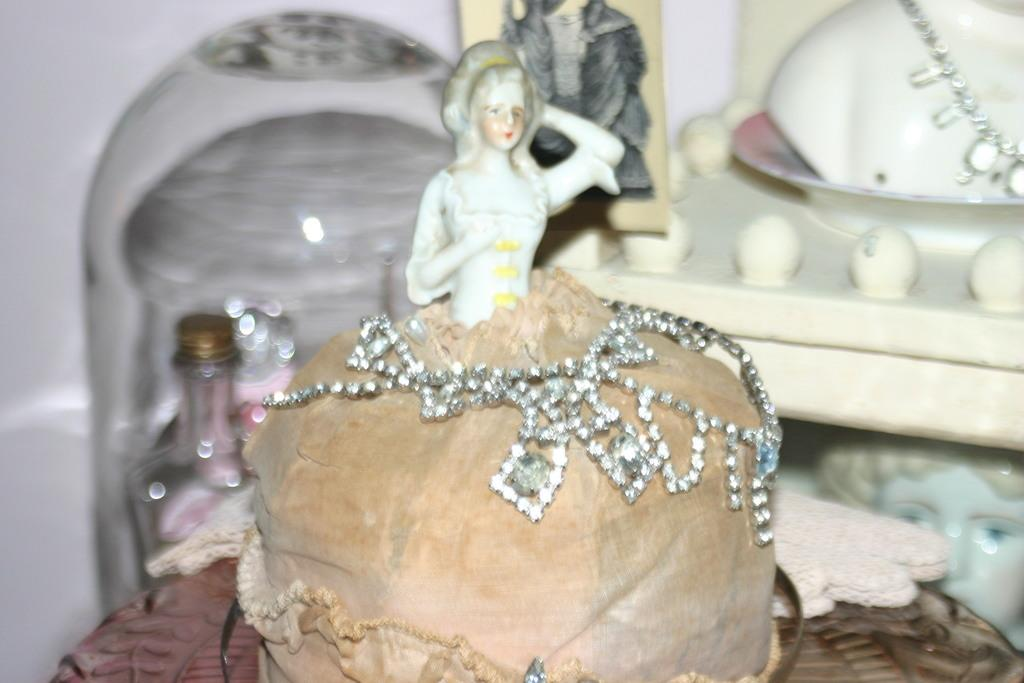What is the main subject of the image? There is a doll in the image. Are there any other dolls visible in the image? Yes, there are dolls in the background of the image. What object can be seen on the left side of the image? There is a bottle on the left side of the image. What type of acoustics can be heard coming from the doll in the image? There is no indication in the image that the doll is making any sounds, so it's not possible to determine what type of acoustics might be heard. 